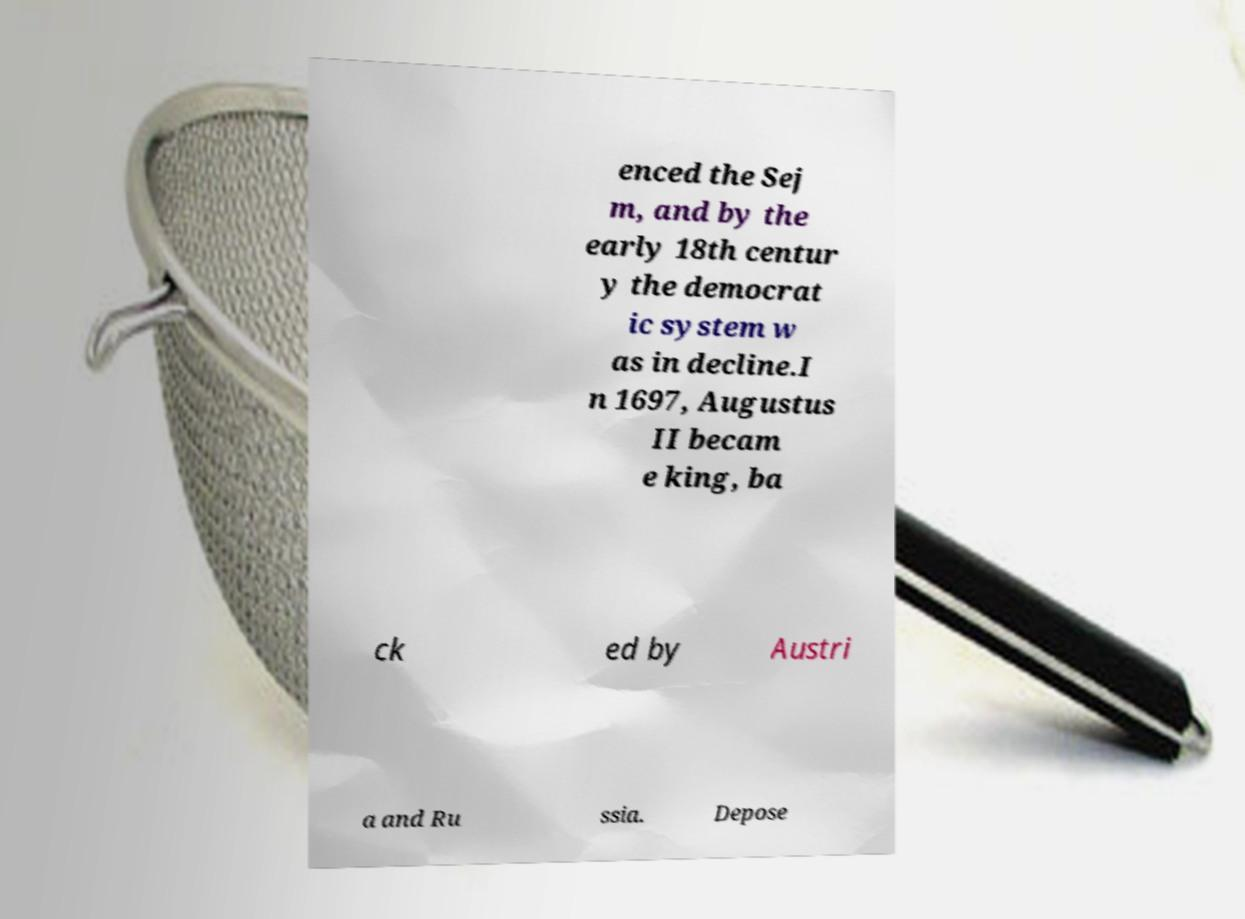What messages or text are displayed in this image? I need them in a readable, typed format. enced the Sej m, and by the early 18th centur y the democrat ic system w as in decline.I n 1697, Augustus II becam e king, ba ck ed by Austri a and Ru ssia. Depose 